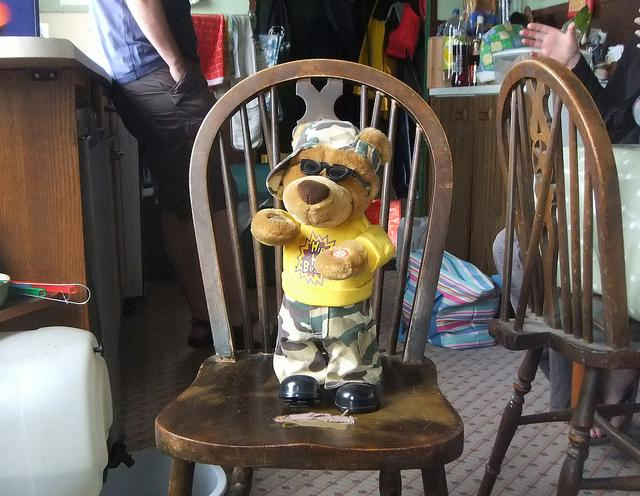What style of pants are these?

Choices:
A) white wash
B) stripped
C) camo
D) polka-dot camo 